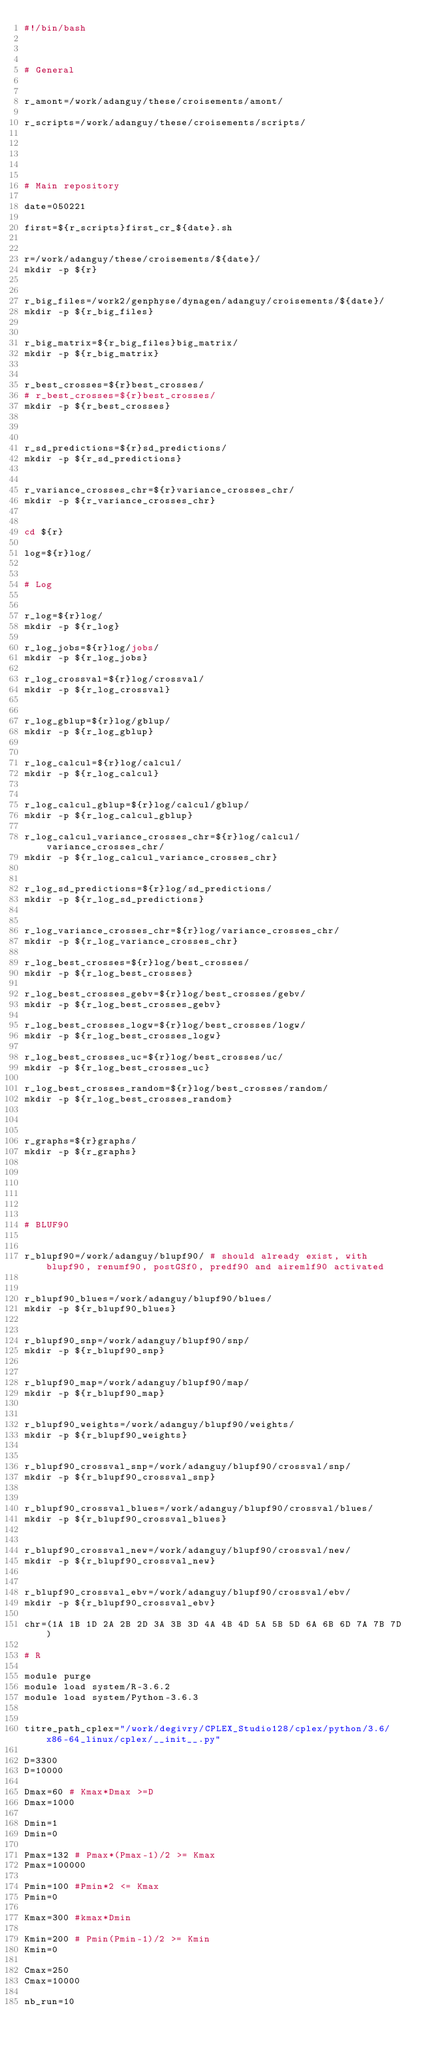<code> <loc_0><loc_0><loc_500><loc_500><_Bash_>#!/bin/bash



# General


r_amont=/work/adanguy/these/croisements/amont/

r_scripts=/work/adanguy/these/croisements/scripts/





# Main repository

date=050221

first=${r_scripts}first_cr_${date}.sh


r=/work/adanguy/these/croisements/${date}/
mkdir -p ${r}


r_big_files=/work2/genphyse/dynagen/adanguy/croisements/${date}/
mkdir -p ${r_big_files}


r_big_matrix=${r_big_files}big_matrix/
mkdir -p ${r_big_matrix}


r_best_crosses=${r}best_crosses/
# r_best_crosses=${r}best_crosses/
mkdir -p ${r_best_crosses}



r_sd_predictions=${r}sd_predictions/
mkdir -p ${r_sd_predictions}


r_variance_crosses_chr=${r}variance_crosses_chr/
mkdir -p ${r_variance_crosses_chr}


cd ${r}

log=${r}log/


# Log


r_log=${r}log/
mkdir -p ${r_log}

r_log_jobs=${r}log/jobs/
mkdir -p ${r_log_jobs}

r_log_crossval=${r}log/crossval/
mkdir -p ${r_log_crossval}


r_log_gblup=${r}log/gblup/
mkdir -p ${r_log_gblup}


r_log_calcul=${r}log/calcul/
mkdir -p ${r_log_calcul}


r_log_calcul_gblup=${r}log/calcul/gblup/
mkdir -p ${r_log_calcul_gblup}

r_log_calcul_variance_crosses_chr=${r}log/calcul/variance_crosses_chr/
mkdir -p ${r_log_calcul_variance_crosses_chr}


r_log_sd_predictions=${r}log/sd_predictions/
mkdir -p ${r_log_sd_predictions}


r_log_variance_crosses_chr=${r}log/variance_crosses_chr/
mkdir -p ${r_log_variance_crosses_chr}

r_log_best_crosses=${r}log/best_crosses/
mkdir -p ${r_log_best_crosses}

r_log_best_crosses_gebv=${r}log/best_crosses/gebv/
mkdir -p ${r_log_best_crosses_gebv}

r_log_best_crosses_logw=${r}log/best_crosses/logw/
mkdir -p ${r_log_best_crosses_logw}

r_log_best_crosses_uc=${r}log/best_crosses/uc/
mkdir -p ${r_log_best_crosses_uc}

r_log_best_crosses_random=${r}log/best_crosses/random/
mkdir -p ${r_log_best_crosses_random}



r_graphs=${r}graphs/
mkdir -p ${r_graphs}






# BLUF90


r_blupf90=/work/adanguy/blupf90/ # should already exist, with blupf90, renumf90, postGSf0, predf90 and airemlf90 activated


r_blupf90_blues=/work/adanguy/blupf90/blues/
mkdir -p ${r_blupf90_blues}


r_blupf90_snp=/work/adanguy/blupf90/snp/
mkdir -p ${r_blupf90_snp}


r_blupf90_map=/work/adanguy/blupf90/map/
mkdir -p ${r_blupf90_map}


r_blupf90_weights=/work/adanguy/blupf90/weights/
mkdir -p ${r_blupf90_weights}


r_blupf90_crossval_snp=/work/adanguy/blupf90/crossval/snp/
mkdir -p ${r_blupf90_crossval_snp}


r_blupf90_crossval_blues=/work/adanguy/blupf90/crossval/blues/
mkdir -p ${r_blupf90_crossval_blues}


r_blupf90_crossval_new=/work/adanguy/blupf90/crossval/new/
mkdir -p ${r_blupf90_crossval_new}


r_blupf90_crossval_ebv=/work/adanguy/blupf90/crossval/ebv/
mkdir -p ${r_blupf90_crossval_ebv}

chr=(1A 1B 1D 2A 2B 2D 3A 3B 3D 4A 4B 4D 5A 5B 5D 6A 6B 6D 7A 7B 7D)

# R

module purge
module load system/R-3.6.2
module load system/Python-3.6.3


titre_path_cplex="/work/degivry/CPLEX_Studio128/cplex/python/3.6/x86-64_linux/cplex/__init__.py"

D=3300
D=10000

Dmax=60 # Kmax*Dmax >=D
Dmax=1000

Dmin=1
Dmin=0

Pmax=132 # Pmax*(Pmax-1)/2 >= Kmax
Pmax=100000

Pmin=100 #Pmin*2 <= Kmax
Pmin=0

Kmax=300 #kmax*Dmin

Kmin=200 # Pmin(Pmin-1)/2 >= Kmin 
Kmin=0

Cmax=250
Cmax=10000

nb_run=10


</code> 